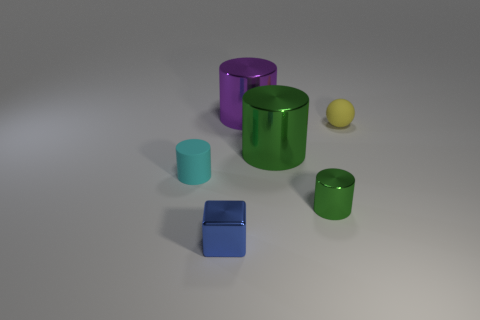What is the material of the other cylinder that is the same color as the tiny shiny cylinder? The other cylinder with the same shiny green finish as the smaller cylinder appears to be made of a similar type of metal, possibly anodized aluminum, which is known for its vibrant, polished appearance and lightweight properties. 